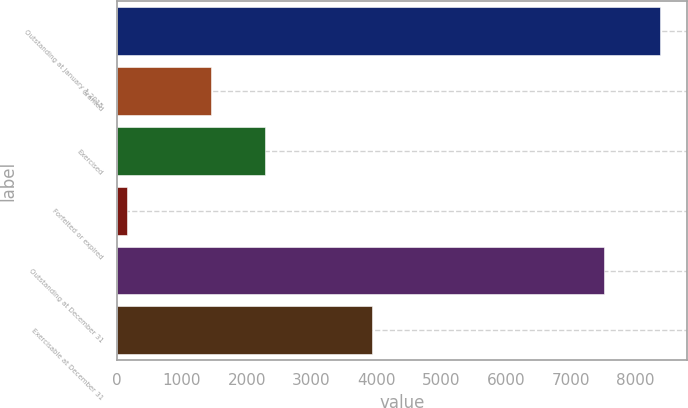Convert chart. <chart><loc_0><loc_0><loc_500><loc_500><bar_chart><fcel>Outstanding at January 1 2015<fcel>Granted<fcel>Exercised<fcel>Forfeited or expired<fcel>Outstanding at December 31<fcel>Exercisable at December 31<nl><fcel>8378<fcel>1455<fcel>2277.2<fcel>156<fcel>7507<fcel>3940<nl></chart> 